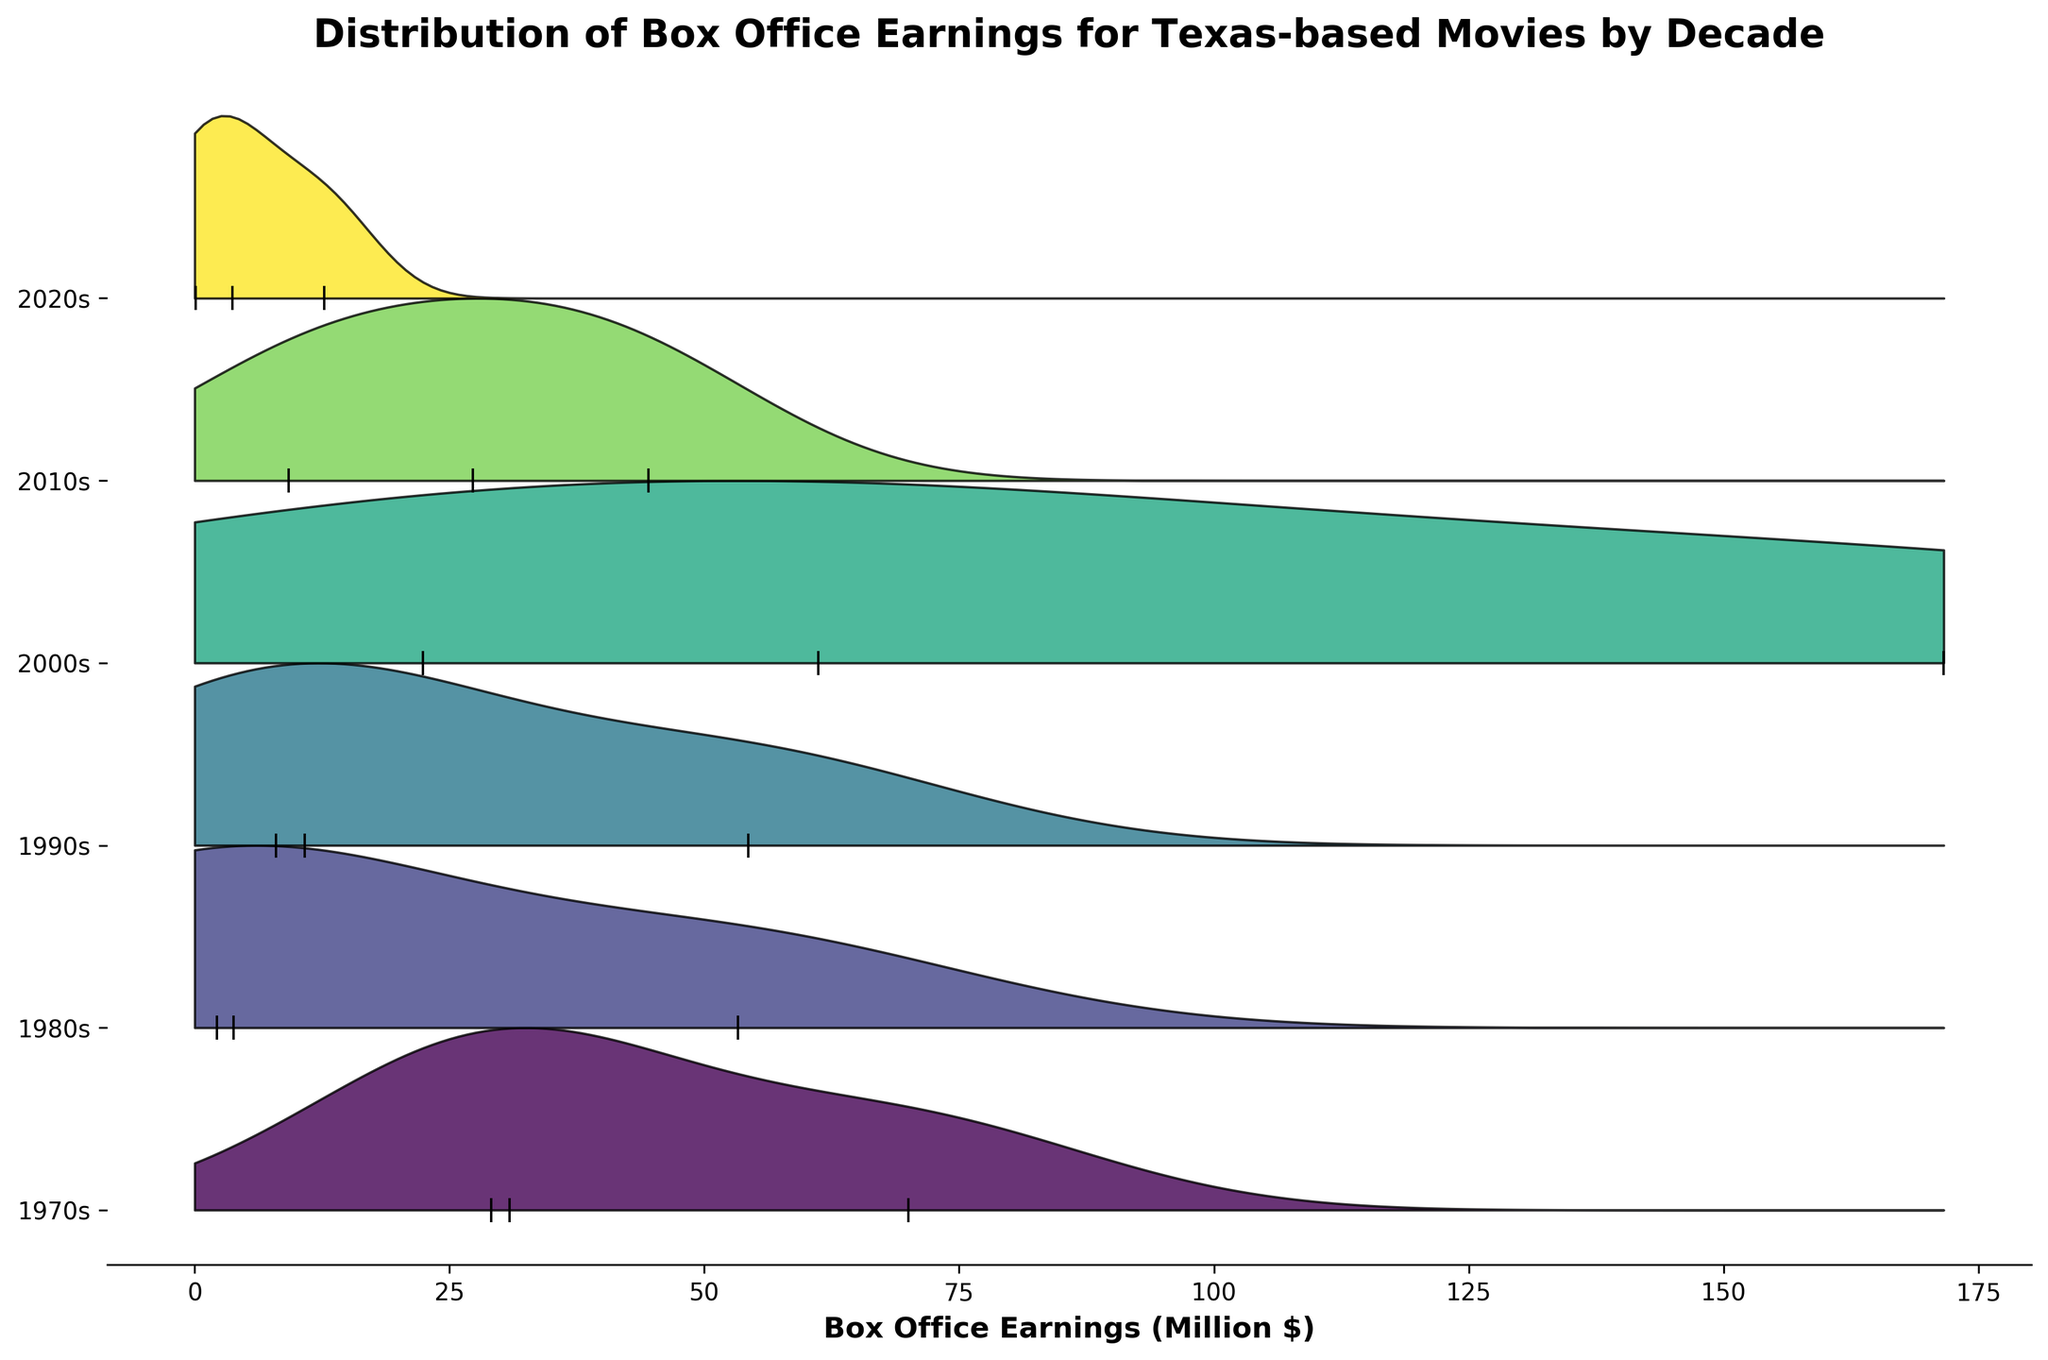What is the title of the plot? The title is usually located at the top of the plot. It is formatted in bold to grab attention. Looking at the top, the title reads "Distribution of Box Office Earnings for Texas-based Movies by Decade".
Answer: Distribution of Box Office Earnings for Texas-based Movies by Decade Which decade has the movie with the highest box office earnings? To find the movie with the highest earnings, look at the horizontal axis which shows earnings and identify the highest value. The highest marked earnings are for "No Country for Old Men" in the 2000s.
Answer: 2000s Which decade has the most concentrated data points on the earnings axis? Identify the decade where the data points (small vertical lines) are clustered closely together along the horizontal axis. The 2010s seem to have many data points closely clustered compared to other decades.
Answer: 2010s What color represents the 1980s in the plot? The plot uses a color gradient where each decade has a different color. The 1980s are represented by a certain color. Looking at the plot, the 1980s seem to be in a light green to yellow hue.
Answer: Light green/yellow Which decade has movies with the least variance in box office earnings? To determine the variance, look at the spread of the earnings around the peak of each decade. The 1980s have movies with very little spread in their earnings compared to other decades.
Answer: 1980s How does the distribution of box office earnings in the 2020s compare to the 1990s? Compare the densities and spread of the data for these two decades. The 2020s have a smaller spread and more concentrated low earnings compared to a wider spread in the 1990s.
Answer: 2020s spread less and lower earnings Which decade has the highest peak in its density plot? The height of the peaks in the density plots indicates concentration. The 2000s show a very noticeable peak, suggesting a high concentration of earnings around a particular value.
Answer: 2000s What is the range of box office earnings for movies in the 1970s? Look from the lowest to the highest data points for the 1970s decade. The range goes from around $29.1 million ("The Last Picture Show") to $70 million ("Bonnie and Clyde").
Answer: $29.1 million to $70 million What does a higher peak in the density plot indicate about the box office earnings of movies in that decade? A higher peak means there is a higher concentration of movies with similar box office earnings values in that range, reflecting consistency in earnings.
Answer: Higher concentration of similar earnings Is there any decade where the movies have earnings below $5 million? Scan the horizontal axis for each decade and look at the distribution; movies in the 1980s, 1990s, and 2020s have data points below $5 million.
Answer: Yes, 1980s, 1990s, and 2020s 